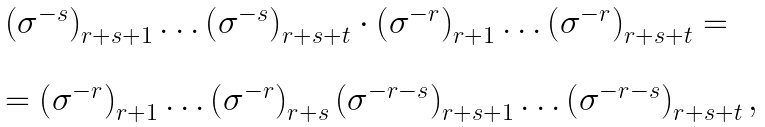Convert formula to latex. <formula><loc_0><loc_0><loc_500><loc_500>\begin{array} { l } \left ( \sigma ^ { - s } \right ) _ { r + s + 1 } \dots \left ( \sigma ^ { - s } \right ) _ { r + s + t } \cdot \left ( \sigma ^ { - r } \right ) _ { r + 1 } \dots \left ( \sigma ^ { - r } \right ) _ { r + s + t } = \\ \\ = \left ( \sigma ^ { - r } \right ) _ { r + 1 } \dots \left ( \sigma ^ { - r } \right ) _ { r + s } \left ( \sigma ^ { - r - s } \right ) _ { r + s + 1 } \dots \left ( \sigma ^ { - r - s } \right ) _ { r + s + t } , \end{array}</formula> 